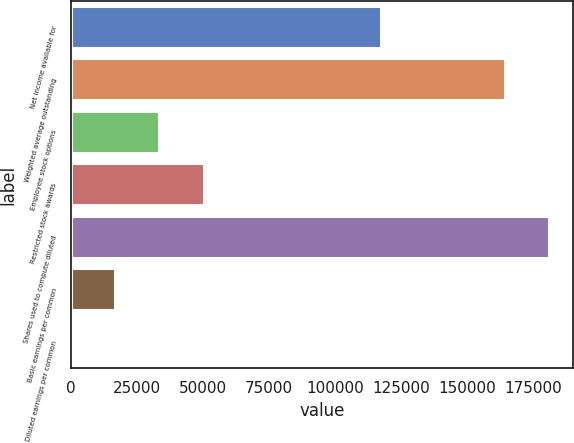Convert chart to OTSL. <chart><loc_0><loc_0><loc_500><loc_500><bar_chart><fcel>Net income available for<fcel>Weighted average outstanding<fcel>Employee stock options<fcel>Restricted stock awards<fcel>Shares used to compute diluted<fcel>Basic earnings per common<fcel>Diluted earnings per common<nl><fcel>117171<fcel>164071<fcel>33462.2<fcel>50192.9<fcel>180802<fcel>16731.4<fcel>0.7<nl></chart> 